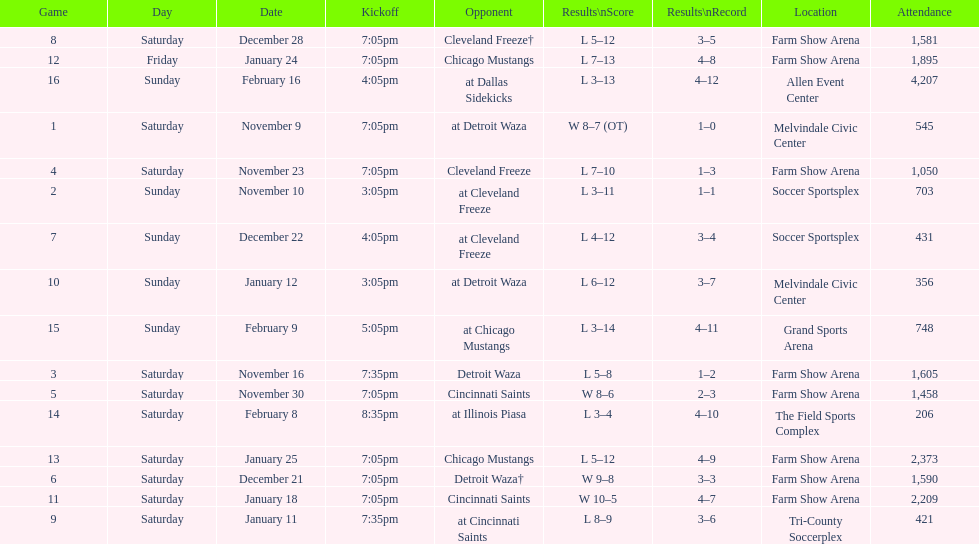Who was the initial adversary on this list? Detroit Waza. 